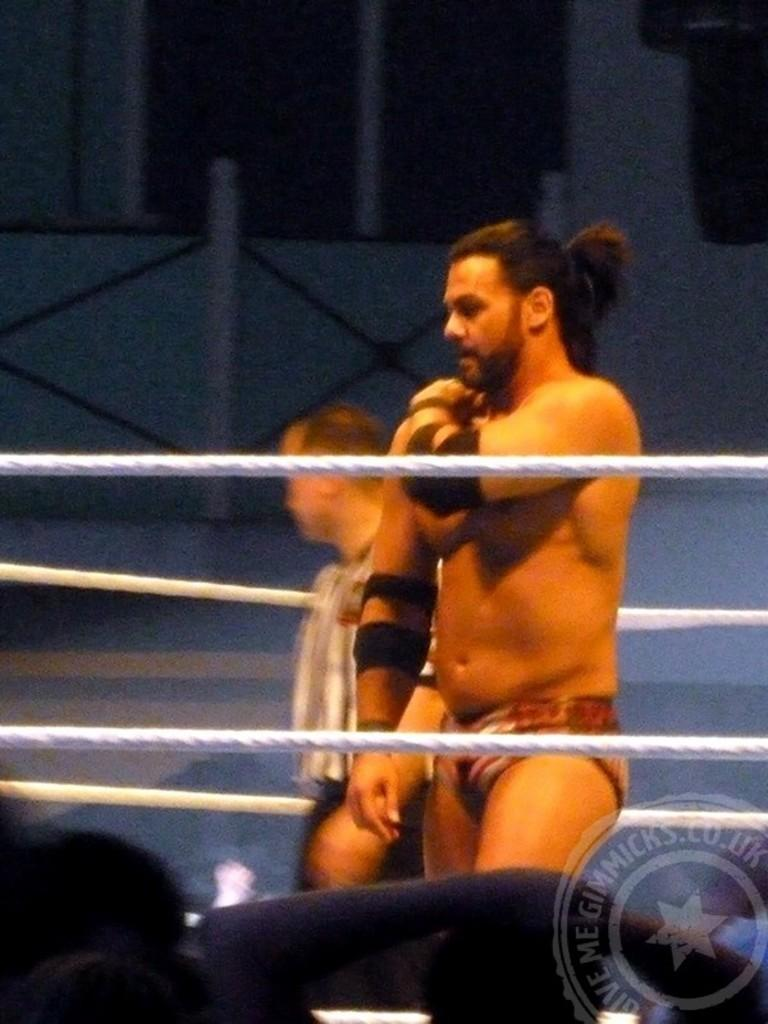How many people are in the image? There are two men in the image. Where are the men located in the image? The men are in the center of the image. What can be seen in the center of the image besides the men? There is a rope boundary in the center of the image. What type of cover is protecting the hydrant in the image? There is no hydrant present in the image, so there is no cover to protect it. 